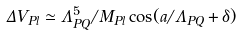Convert formula to latex. <formula><loc_0><loc_0><loc_500><loc_500>\Delta V _ { P l } \simeq \Lambda ^ { 5 } _ { P Q } / M _ { P l } \cos ( a / \Lambda _ { P Q } + \delta )</formula> 